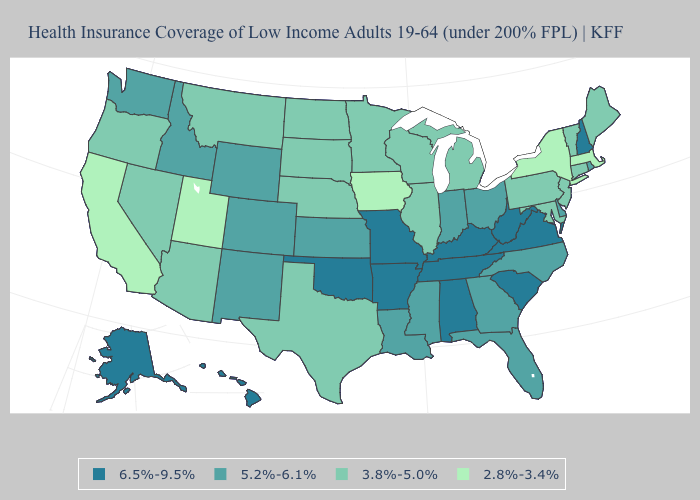Does the map have missing data?
Give a very brief answer. No. Name the states that have a value in the range 5.2%-6.1%?
Concise answer only. Colorado, Delaware, Florida, Georgia, Idaho, Indiana, Kansas, Louisiana, Mississippi, New Mexico, North Carolina, Ohio, Rhode Island, Washington, Wyoming. What is the value of Wisconsin?
Answer briefly. 3.8%-5.0%. Name the states that have a value in the range 3.8%-5.0%?
Write a very short answer. Arizona, Connecticut, Illinois, Maine, Maryland, Michigan, Minnesota, Montana, Nebraska, Nevada, New Jersey, North Dakota, Oregon, Pennsylvania, South Dakota, Texas, Vermont, Wisconsin. What is the highest value in states that border Maryland?
Answer briefly. 6.5%-9.5%. Among the states that border Rhode Island , does Massachusetts have the lowest value?
Short answer required. Yes. What is the value of Connecticut?
Concise answer only. 3.8%-5.0%. Name the states that have a value in the range 3.8%-5.0%?
Quick response, please. Arizona, Connecticut, Illinois, Maine, Maryland, Michigan, Minnesota, Montana, Nebraska, Nevada, New Jersey, North Dakota, Oregon, Pennsylvania, South Dakota, Texas, Vermont, Wisconsin. Name the states that have a value in the range 2.8%-3.4%?
Give a very brief answer. California, Iowa, Massachusetts, New York, Utah. Which states have the lowest value in the USA?
Write a very short answer. California, Iowa, Massachusetts, New York, Utah. Does the first symbol in the legend represent the smallest category?
Short answer required. No. Name the states that have a value in the range 3.8%-5.0%?
Quick response, please. Arizona, Connecticut, Illinois, Maine, Maryland, Michigan, Minnesota, Montana, Nebraska, Nevada, New Jersey, North Dakota, Oregon, Pennsylvania, South Dakota, Texas, Vermont, Wisconsin. Does the map have missing data?
Write a very short answer. No. What is the highest value in the USA?
Be succinct. 6.5%-9.5%. What is the value of Georgia?
Short answer required. 5.2%-6.1%. 